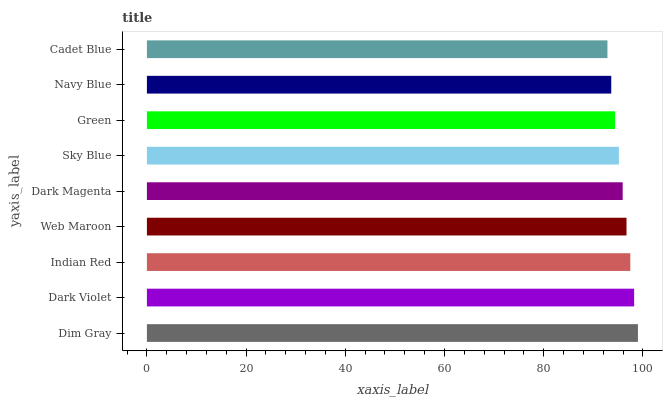Is Cadet Blue the minimum?
Answer yes or no. Yes. Is Dim Gray the maximum?
Answer yes or no. Yes. Is Dark Violet the minimum?
Answer yes or no. No. Is Dark Violet the maximum?
Answer yes or no. No. Is Dim Gray greater than Dark Violet?
Answer yes or no. Yes. Is Dark Violet less than Dim Gray?
Answer yes or no. Yes. Is Dark Violet greater than Dim Gray?
Answer yes or no. No. Is Dim Gray less than Dark Violet?
Answer yes or no. No. Is Dark Magenta the high median?
Answer yes or no. Yes. Is Dark Magenta the low median?
Answer yes or no. Yes. Is Dim Gray the high median?
Answer yes or no. No. Is Sky Blue the low median?
Answer yes or no. No. 